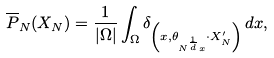<formula> <loc_0><loc_0><loc_500><loc_500>\overline { P } _ { N } ( X _ { N } ) = \frac { 1 } { | \Omega | } \int _ { \Omega } \delta _ { \left ( x , \theta _ { N ^ { \frac { 1 } { d } } x } \cdot X _ { N } ^ { \prime } \right ) } \, d x ,</formula> 